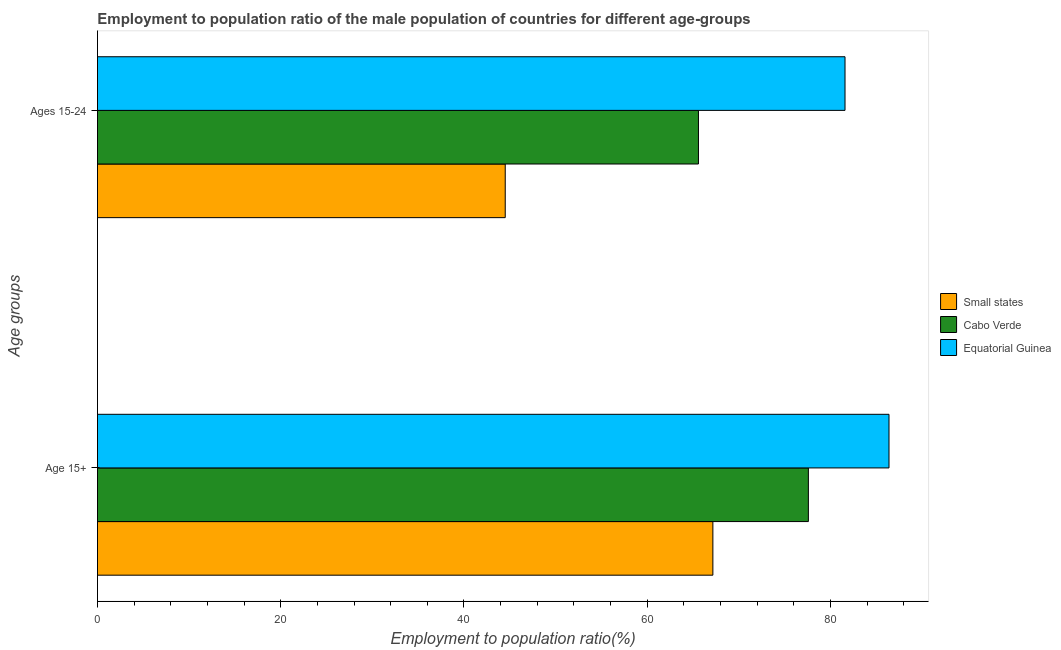How many groups of bars are there?
Offer a terse response. 2. Are the number of bars per tick equal to the number of legend labels?
Offer a very short reply. Yes. How many bars are there on the 1st tick from the top?
Provide a succinct answer. 3. How many bars are there on the 2nd tick from the bottom?
Provide a short and direct response. 3. What is the label of the 2nd group of bars from the top?
Make the answer very short. Age 15+. What is the employment to population ratio(age 15+) in Small states?
Offer a terse response. 67.17. Across all countries, what is the maximum employment to population ratio(age 15-24)?
Your answer should be very brief. 81.6. Across all countries, what is the minimum employment to population ratio(age 15+)?
Your answer should be very brief. 67.17. In which country was the employment to population ratio(age 15-24) maximum?
Ensure brevity in your answer.  Equatorial Guinea. In which country was the employment to population ratio(age 15-24) minimum?
Provide a succinct answer. Small states. What is the total employment to population ratio(age 15-24) in the graph?
Your answer should be compact. 191.71. What is the difference between the employment to population ratio(age 15+) in Equatorial Guinea and that in Cabo Verde?
Your answer should be very brief. 8.8. What is the difference between the employment to population ratio(age 15-24) in Cabo Verde and the employment to population ratio(age 15+) in Equatorial Guinea?
Make the answer very short. -20.8. What is the average employment to population ratio(age 15-24) per country?
Offer a terse response. 63.9. What is the difference between the employment to population ratio(age 15-24) and employment to population ratio(age 15+) in Equatorial Guinea?
Give a very brief answer. -4.8. What is the ratio of the employment to population ratio(age 15-24) in Small states to that in Cabo Verde?
Your response must be concise. 0.68. Is the employment to population ratio(age 15-24) in Small states less than that in Equatorial Guinea?
Make the answer very short. Yes. In how many countries, is the employment to population ratio(age 15+) greater than the average employment to population ratio(age 15+) taken over all countries?
Ensure brevity in your answer.  2. What does the 1st bar from the top in Ages 15-24 represents?
Your response must be concise. Equatorial Guinea. What does the 2nd bar from the bottom in Ages 15-24 represents?
Give a very brief answer. Cabo Verde. Are all the bars in the graph horizontal?
Offer a terse response. Yes. Are the values on the major ticks of X-axis written in scientific E-notation?
Your answer should be compact. No. Where does the legend appear in the graph?
Ensure brevity in your answer.  Center right. How many legend labels are there?
Your response must be concise. 3. How are the legend labels stacked?
Provide a succinct answer. Vertical. What is the title of the graph?
Your response must be concise. Employment to population ratio of the male population of countries for different age-groups. Does "Luxembourg" appear as one of the legend labels in the graph?
Offer a very short reply. No. What is the label or title of the X-axis?
Offer a very short reply. Employment to population ratio(%). What is the label or title of the Y-axis?
Provide a short and direct response. Age groups. What is the Employment to population ratio(%) in Small states in Age 15+?
Make the answer very short. 67.17. What is the Employment to population ratio(%) in Cabo Verde in Age 15+?
Your answer should be very brief. 77.6. What is the Employment to population ratio(%) in Equatorial Guinea in Age 15+?
Keep it short and to the point. 86.4. What is the Employment to population ratio(%) of Small states in Ages 15-24?
Ensure brevity in your answer.  44.51. What is the Employment to population ratio(%) of Cabo Verde in Ages 15-24?
Ensure brevity in your answer.  65.6. What is the Employment to population ratio(%) of Equatorial Guinea in Ages 15-24?
Provide a short and direct response. 81.6. Across all Age groups, what is the maximum Employment to population ratio(%) in Small states?
Provide a short and direct response. 67.17. Across all Age groups, what is the maximum Employment to population ratio(%) in Cabo Verde?
Ensure brevity in your answer.  77.6. Across all Age groups, what is the maximum Employment to population ratio(%) of Equatorial Guinea?
Offer a very short reply. 86.4. Across all Age groups, what is the minimum Employment to population ratio(%) of Small states?
Ensure brevity in your answer.  44.51. Across all Age groups, what is the minimum Employment to population ratio(%) in Cabo Verde?
Offer a very short reply. 65.6. Across all Age groups, what is the minimum Employment to population ratio(%) in Equatorial Guinea?
Your answer should be very brief. 81.6. What is the total Employment to population ratio(%) in Small states in the graph?
Offer a terse response. 111.68. What is the total Employment to population ratio(%) in Cabo Verde in the graph?
Keep it short and to the point. 143.2. What is the total Employment to population ratio(%) in Equatorial Guinea in the graph?
Make the answer very short. 168. What is the difference between the Employment to population ratio(%) of Small states in Age 15+ and that in Ages 15-24?
Ensure brevity in your answer.  22.67. What is the difference between the Employment to population ratio(%) of Small states in Age 15+ and the Employment to population ratio(%) of Cabo Verde in Ages 15-24?
Provide a short and direct response. 1.57. What is the difference between the Employment to population ratio(%) of Small states in Age 15+ and the Employment to population ratio(%) of Equatorial Guinea in Ages 15-24?
Your response must be concise. -14.43. What is the average Employment to population ratio(%) of Small states per Age groups?
Offer a very short reply. 55.84. What is the average Employment to population ratio(%) of Cabo Verde per Age groups?
Your answer should be very brief. 71.6. What is the difference between the Employment to population ratio(%) of Small states and Employment to population ratio(%) of Cabo Verde in Age 15+?
Your answer should be compact. -10.43. What is the difference between the Employment to population ratio(%) in Small states and Employment to population ratio(%) in Equatorial Guinea in Age 15+?
Keep it short and to the point. -19.23. What is the difference between the Employment to population ratio(%) of Small states and Employment to population ratio(%) of Cabo Verde in Ages 15-24?
Your response must be concise. -21.09. What is the difference between the Employment to population ratio(%) of Small states and Employment to population ratio(%) of Equatorial Guinea in Ages 15-24?
Provide a short and direct response. -37.09. What is the ratio of the Employment to population ratio(%) of Small states in Age 15+ to that in Ages 15-24?
Offer a very short reply. 1.51. What is the ratio of the Employment to population ratio(%) of Cabo Verde in Age 15+ to that in Ages 15-24?
Offer a very short reply. 1.18. What is the ratio of the Employment to population ratio(%) in Equatorial Guinea in Age 15+ to that in Ages 15-24?
Keep it short and to the point. 1.06. What is the difference between the highest and the second highest Employment to population ratio(%) in Small states?
Ensure brevity in your answer.  22.67. What is the difference between the highest and the lowest Employment to population ratio(%) in Small states?
Give a very brief answer. 22.67. 